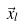Convert formula to latex. <formula><loc_0><loc_0><loc_500><loc_500>\vec { x } _ { l }</formula> 